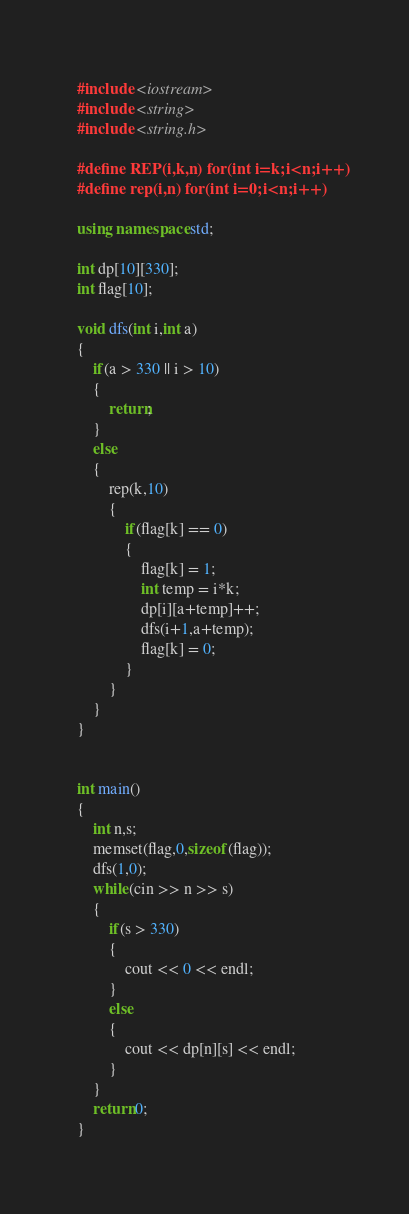Convert code to text. <code><loc_0><loc_0><loc_500><loc_500><_C++_>#include <iostream>
#include <string>
#include <string.h>

#define REP(i,k,n) for(int i=k;i<n;i++)
#define rep(i,n) for(int i=0;i<n;i++)

using namespace std;

int dp[10][330];
int flag[10];

void dfs(int i,int a)
{
	if(a > 330 || i > 10)
	{
		return;
	}
	else
	{
		rep(k,10)
		{
			if(flag[k] == 0)
			{
				flag[k] = 1;
				int temp = i*k;
				dp[i][a+temp]++;
				dfs(i+1,a+temp);
				flag[k] = 0;
			}
		}
	}
}


int main()
{
	int n,s;
	memset(flag,0,sizeof(flag));
	dfs(1,0);
	while(cin >> n >> s)
	{
		if(s > 330)
		{
			cout << 0 << endl;
		}
		else
		{
			cout << dp[n][s] << endl;
		}
	}
	return 0;
}</code> 